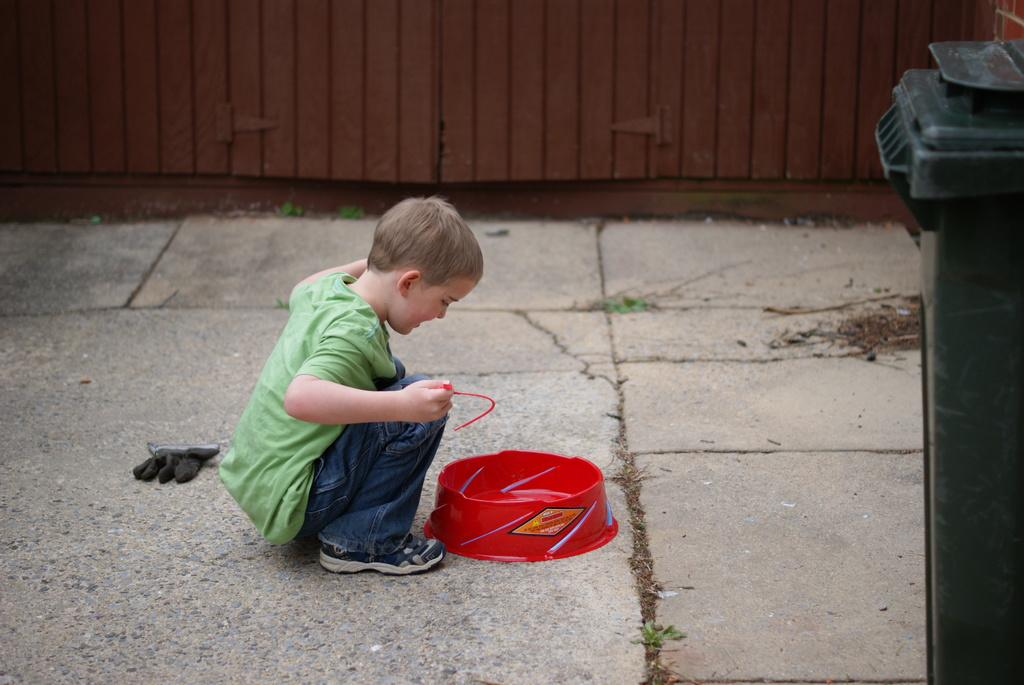What is the main subject of the image? The main subject of the image is a kid. What is the kid doing in the image? The kid is in front of a bowl. What can be seen at the top of the image? There is a door at the top of the image. What object is located on the right side of the image? There is a trash bin on the right side of the image. How many sisters does the kid have in the image? There is no information about the kid's sisters in the image. What type of market is visible in the image? There is no market present in the image. 